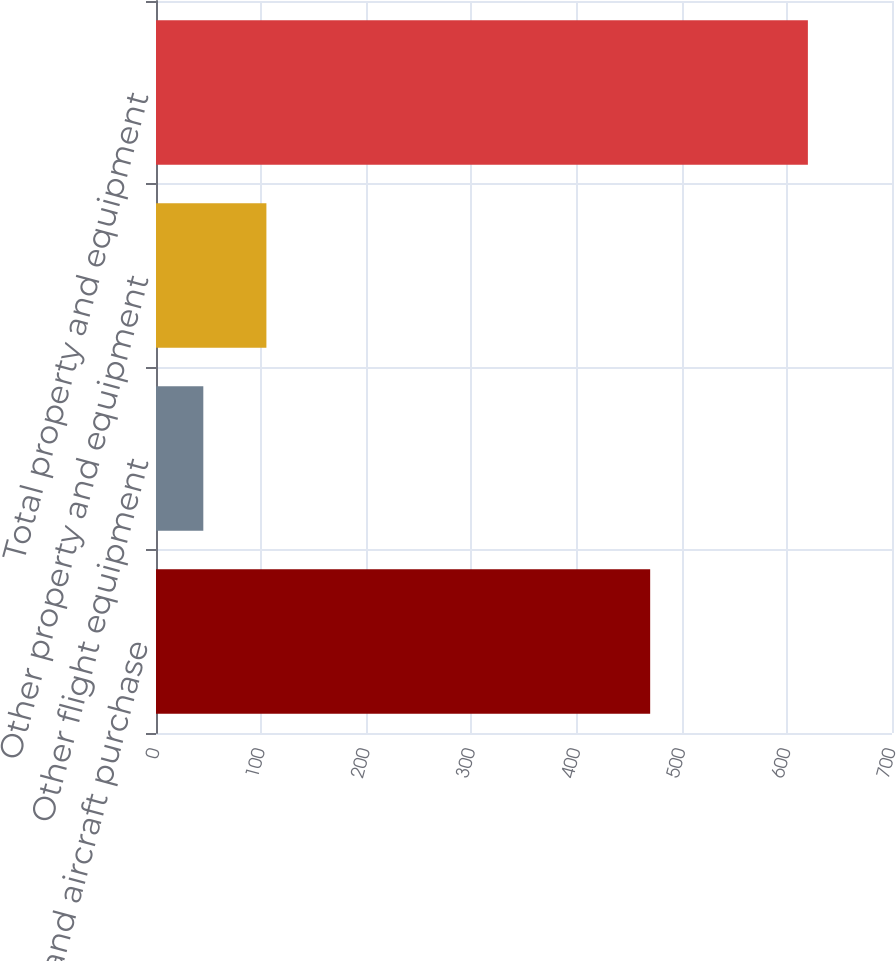Convert chart to OTSL. <chart><loc_0><loc_0><loc_500><loc_500><bar_chart><fcel>Aircraft and aircraft purchase<fcel>Other flight equipment<fcel>Other property and equipment<fcel>Total property and equipment<nl><fcel>470<fcel>45<fcel>105<fcel>620<nl></chart> 